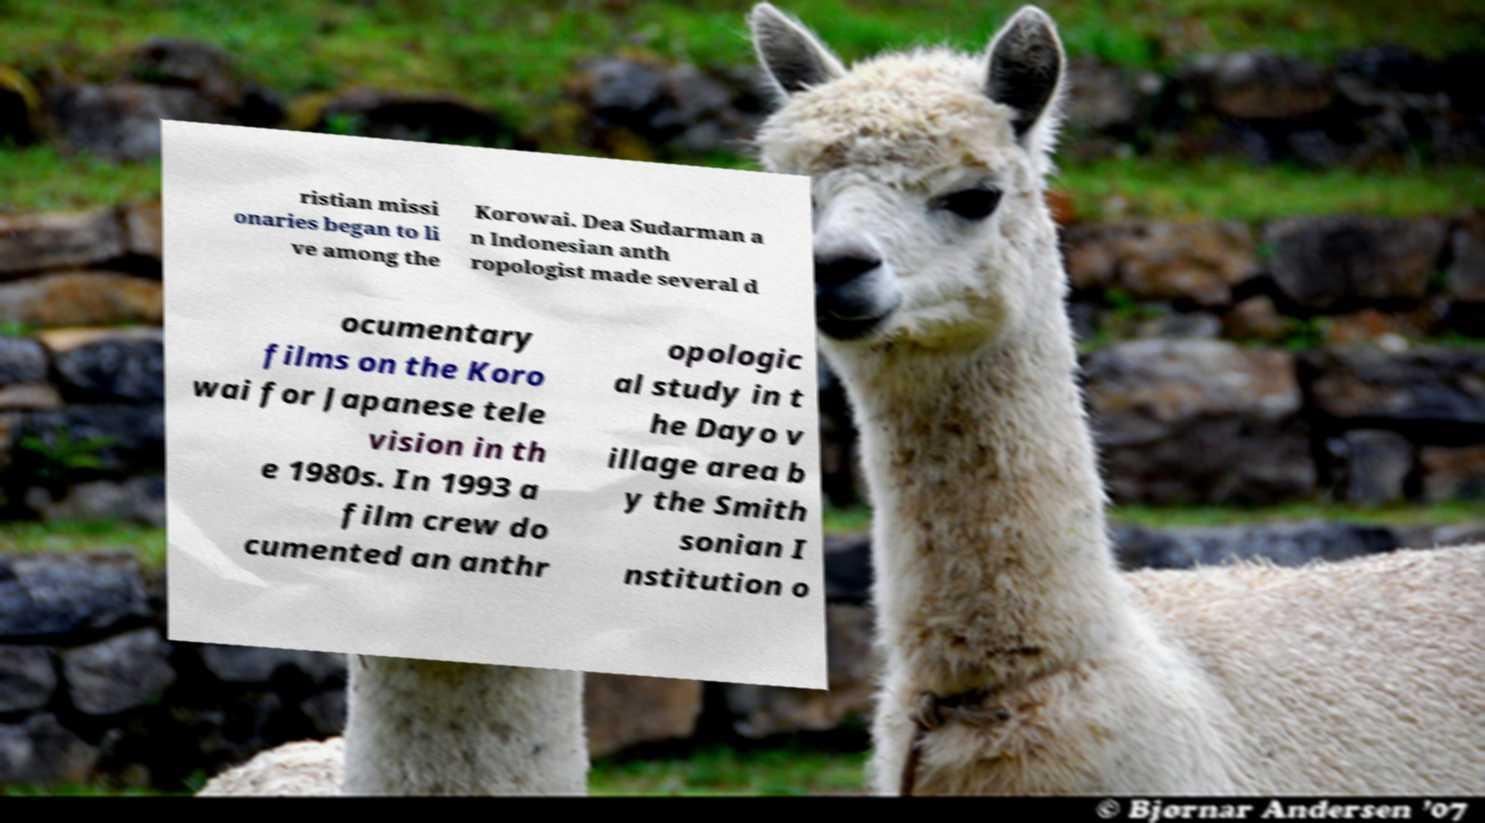Please identify and transcribe the text found in this image. ristian missi onaries began to li ve among the Korowai. Dea Sudarman a n Indonesian anth ropologist made several d ocumentary films on the Koro wai for Japanese tele vision in th e 1980s. In 1993 a film crew do cumented an anthr opologic al study in t he Dayo v illage area b y the Smith sonian I nstitution o 